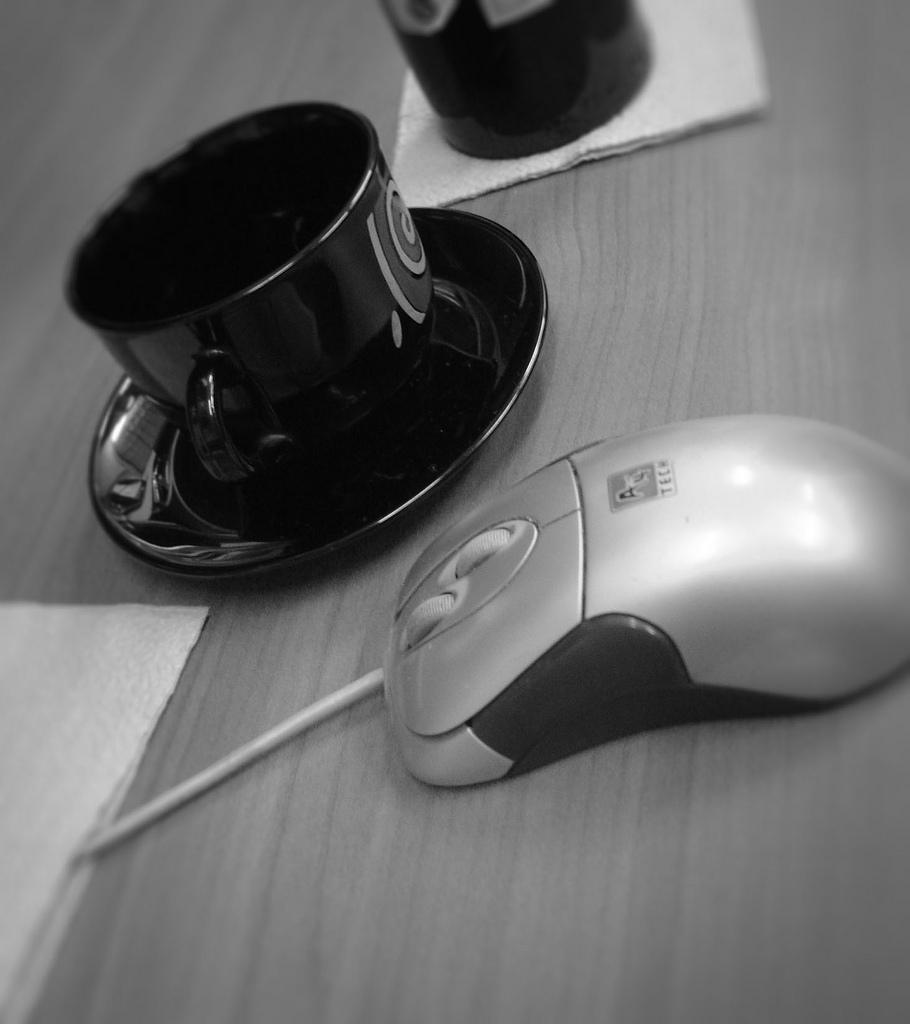How many cups are there?
Give a very brief answer. 2. How many cups?
Give a very brief answer. 2. How many napkins?
Give a very brief answer. 2. How many cups with saucers?
Give a very brief answer. 1. How many rollers are on the mouse?
Give a very brief answer. 2. How many wheels are on the mouse?
Give a very brief answer. 2. How many mugs?
Give a very brief answer. 1. 